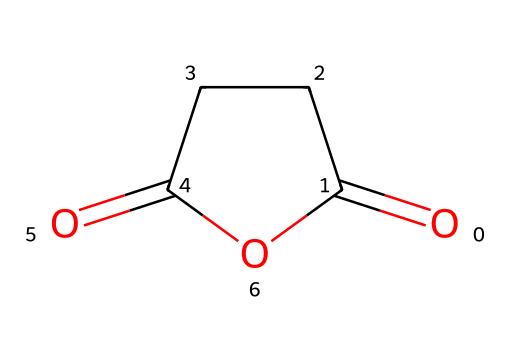What is the name of this chemical? The structure corresponds to succinic anhydride, which is formed from succinic acid by the loss of water between its carboxylic acid groups.
Answer: succinic anhydride How many carbon atoms are in this chemical? Counting the carbon atoms in the SMILES representation shows there are four carbon atoms present in the structure of succinic anhydride.
Answer: four What type of bond connects the carbonyl functional groups? The carbonyl groups in succinic anhydride are connected by a single bond, typically a sigma bond, that links the carbon atoms in the cycle.
Answer: single bond What is the hybridization of the carbon atoms in the carbonyl groups? The carbon atoms in the carbonyl groups are sp2 hybridized, as each participates in a double bond with oxygen and a single bond with adjacent carbon.
Answer: sp2 Does this chemical act as a preservative? Succinic anhydride can function as a preservative due to its ability to form cyclic anhydrides that contribute to conserving food and drink products.
Answer: yes What structural feature characterizes acid anhydrides like this one? Acid anhydrides are characterized by having two carbonyl (C=O) groups related through an oxygen atom, which is evident in the cyclical form of succinic anhydride.
Answer: two carbonyl groups How many oxygen atoms are present in this chemical? The SMILES representation indicates two oxygen atoms in the structure of succinic anhydride, one for each carbonyl group.
Answer: two 